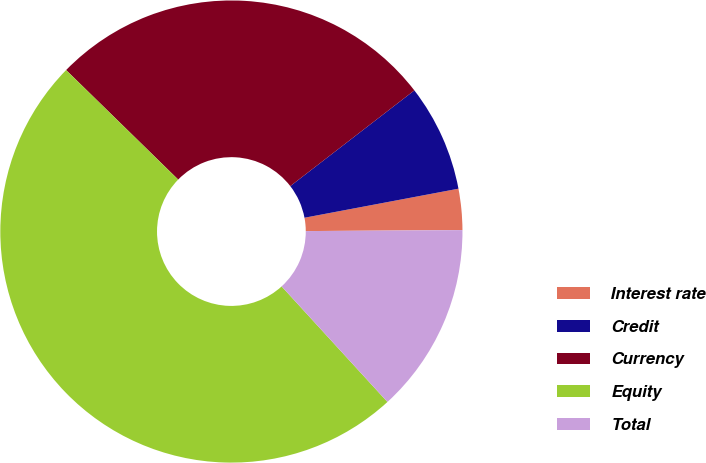<chart> <loc_0><loc_0><loc_500><loc_500><pie_chart><fcel>Interest rate<fcel>Credit<fcel>Currency<fcel>Equity<fcel>Total<nl><fcel>2.87%<fcel>7.49%<fcel>27.23%<fcel>49.12%<fcel>13.3%<nl></chart> 